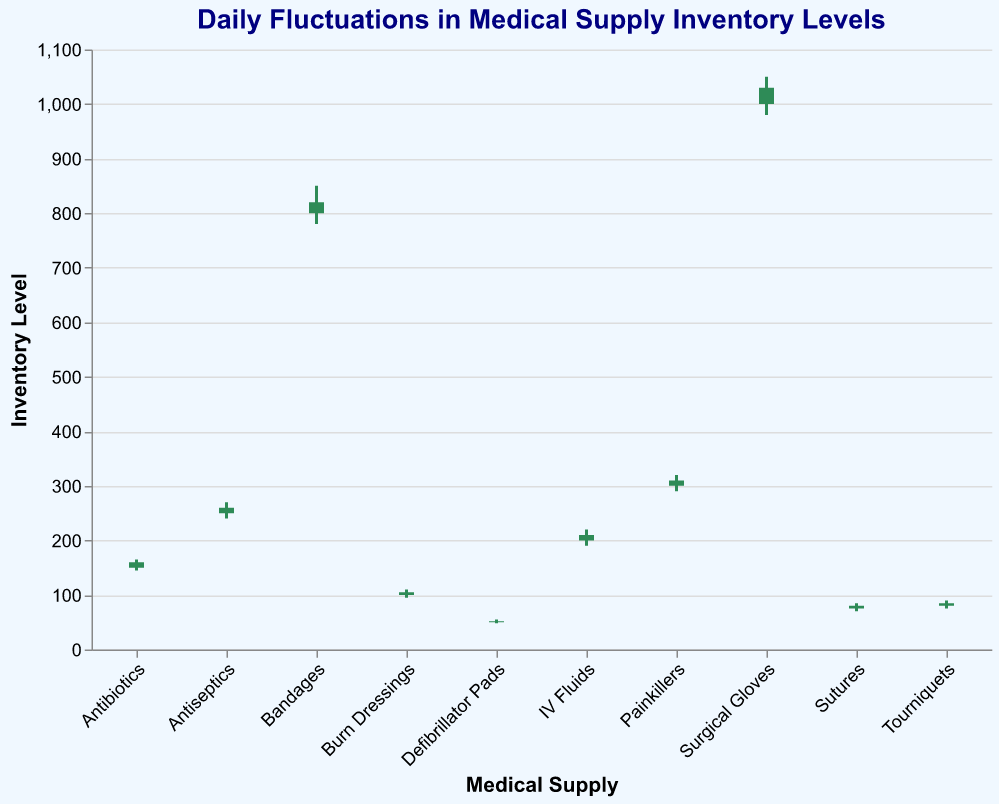What's the title of the figure? The title of the figure is usually located at the top of the plot. It directly states what the figure is about. In this case, the title is "Daily Fluctuations in Medical Supply Inventory Levels."
Answer: Daily Fluctuations in Medical Supply Inventory Levels Which medical supply had the highest 'High' inventory level, and what was the value? To find this, look at the 'High' values for each medical supply and identify the highest one. Surgical Gloves had the highest 'High' value of 1050.
Answer: Surgical Gloves, 1050 How many medical supplies had their 'Close' value lower than their 'Open' value? The supplies where 'Close' is less than 'Open' are colored differently. By counting the red (crimson) bars in the plot, you can identify the supplies. There are 3 such supplies: Bandages, Surgical Gloves, and Defibrillator Pads.
Answer: 3 supplies Which medical supply had the smallest range between its 'High' and 'Low' values, and what was the range? Compute the range (High - Low) for each supply and find the smallest one. Defibrillator Pads had the smallest range: 55 - 48 = 7.
Answer: Defibrillator Pads, 7 Did any medical supply's 'Close' value match its 'High' value? Compare the 'Close' and 'High' values for each supply to see if they match. None of the supplies have 'Close' values matching their 'High' values.
Answer: No Which supplies show an increase in inventory from open to close? Supplies where 'Close' is greater than 'Open' are colored green (seagreen). These supplies are Antibiotics, Painkillers, IV Fluids, Sutures, Antiseptics, Burn Dressings, and Tourniquets.
Answer: 7 supplies What's the average 'Close' value for all medical supplies? Add up all 'Close' values and divide by the number of supplies: (160 + 820 + 310 + 210 + 1030 + 80 + 260 + 105 + 52 + 85) / 10. The sum is 3112, and the average is 311.2.
Answer: 311.2 Which medical supply had the greatest drop in inventory from 'Open' to 'Close', and what was the difference? Calculate the difference (Open - Close) for each supply and find the largest drop. Surgical Gloves had the greatest drop, 1000 - 1030 = -30, but since it's an increase, Bandages with 800 - 820=-20 shows the drop.
Answer: Bandages, 20 What's the total range of inventory levels (High - Low) for all medical supplies combined? Sum the individual ranges (High - Low) for each supply: (165-145) + (850-780) + (320-290) + (220-190) + (1050-980) + (85-70) + (270-240) + (110-95) + (55-48) + (90-75) = 20 + 70 + 30 + 30 + 70 + 15 + 30 + 15 + 7 + 15 = 302.
Answer: 302 